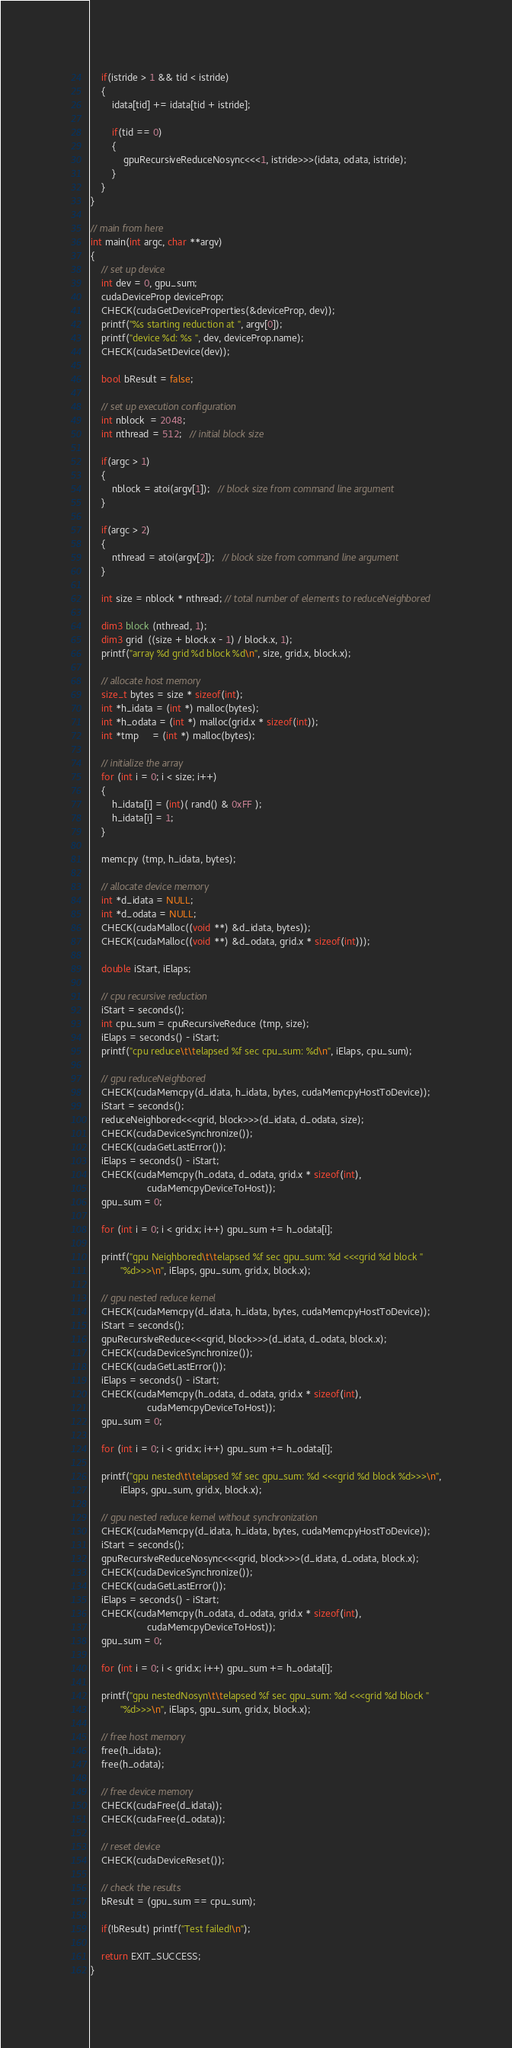Convert code to text. <code><loc_0><loc_0><loc_500><loc_500><_Cuda_>
    if(istride > 1 && tid < istride)
    {
        idata[tid] += idata[tid + istride];

        if(tid == 0)
        {
            gpuRecursiveReduceNosync<<<1, istride>>>(idata, odata, istride);
        }
    }
}

// main from here
int main(int argc, char **argv)
{
    // set up device
    int dev = 0, gpu_sum;
    cudaDeviceProp deviceProp;
    CHECK(cudaGetDeviceProperties(&deviceProp, dev));
    printf("%s starting reduction at ", argv[0]);
    printf("device %d: %s ", dev, deviceProp.name);
    CHECK(cudaSetDevice(dev));

    bool bResult = false;

    // set up execution configuration
    int nblock  = 2048;
    int nthread = 512;   // initial block size

    if(argc > 1)
    {
        nblock = atoi(argv[1]);   // block size from command line argument
    }

    if(argc > 2)
    {
        nthread = atoi(argv[2]);   // block size from command line argument
    }

    int size = nblock * nthread; // total number of elements to reduceNeighbored

    dim3 block (nthread, 1);
    dim3 grid  ((size + block.x - 1) / block.x, 1);
    printf("array %d grid %d block %d\n", size, grid.x, block.x);

    // allocate host memory
    size_t bytes = size * sizeof(int);
    int *h_idata = (int *) malloc(bytes);
    int *h_odata = (int *) malloc(grid.x * sizeof(int));
    int *tmp     = (int *) malloc(bytes);

    // initialize the array
    for (int i = 0; i < size; i++)
    {
        h_idata[i] = (int)( rand() & 0xFF );
        h_idata[i] = 1;
    }

    memcpy (tmp, h_idata, bytes);

    // allocate device memory
    int *d_idata = NULL;
    int *d_odata = NULL;
    CHECK(cudaMalloc((void **) &d_idata, bytes));
    CHECK(cudaMalloc((void **) &d_odata, grid.x * sizeof(int)));

    double iStart, iElaps;

    // cpu recursive reduction
    iStart = seconds();
    int cpu_sum = cpuRecursiveReduce (tmp, size);
    iElaps = seconds() - iStart;
    printf("cpu reduce\t\telapsed %f sec cpu_sum: %d\n", iElaps, cpu_sum);

    // gpu reduceNeighbored
    CHECK(cudaMemcpy(d_idata, h_idata, bytes, cudaMemcpyHostToDevice));
    iStart = seconds();
    reduceNeighbored<<<grid, block>>>(d_idata, d_odata, size);
    CHECK(cudaDeviceSynchronize());
    CHECK(cudaGetLastError());
    iElaps = seconds() - iStart;
    CHECK(cudaMemcpy(h_odata, d_odata, grid.x * sizeof(int),
                     cudaMemcpyDeviceToHost));
    gpu_sum = 0;

    for (int i = 0; i < grid.x; i++) gpu_sum += h_odata[i];

    printf("gpu Neighbored\t\telapsed %f sec gpu_sum: %d <<<grid %d block "
           "%d>>>\n", iElaps, gpu_sum, grid.x, block.x);

    // gpu nested reduce kernel
    CHECK(cudaMemcpy(d_idata, h_idata, bytes, cudaMemcpyHostToDevice));
    iStart = seconds();
    gpuRecursiveReduce<<<grid, block>>>(d_idata, d_odata, block.x);
    CHECK(cudaDeviceSynchronize());
    CHECK(cudaGetLastError());
    iElaps = seconds() - iStart;
    CHECK(cudaMemcpy(h_odata, d_odata, grid.x * sizeof(int),
                     cudaMemcpyDeviceToHost));
    gpu_sum = 0;

    for (int i = 0; i < grid.x; i++) gpu_sum += h_odata[i];

    printf("gpu nested\t\telapsed %f sec gpu_sum: %d <<<grid %d block %d>>>\n",
           iElaps, gpu_sum, grid.x, block.x);

    // gpu nested reduce kernel without synchronization
    CHECK(cudaMemcpy(d_idata, h_idata, bytes, cudaMemcpyHostToDevice));
    iStart = seconds();
    gpuRecursiveReduceNosync<<<grid, block>>>(d_idata, d_odata, block.x);
    CHECK(cudaDeviceSynchronize());
    CHECK(cudaGetLastError());
    iElaps = seconds() - iStart;
    CHECK(cudaMemcpy(h_odata, d_odata, grid.x * sizeof(int),
                     cudaMemcpyDeviceToHost));
    gpu_sum = 0;

    for (int i = 0; i < grid.x; i++) gpu_sum += h_odata[i];

    printf("gpu nestedNosyn\t\telapsed %f sec gpu_sum: %d <<<grid %d block "
           "%d>>>\n", iElaps, gpu_sum, grid.x, block.x);

    // free host memory
    free(h_idata);
    free(h_odata);

    // free device memory
    CHECK(cudaFree(d_idata));
    CHECK(cudaFree(d_odata));

    // reset device
    CHECK(cudaDeviceReset());

    // check the results
    bResult = (gpu_sum == cpu_sum);

    if(!bResult) printf("Test failed!\n");

    return EXIT_SUCCESS;
}
</code> 